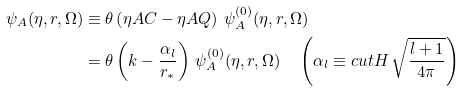Convert formula to latex. <formula><loc_0><loc_0><loc_500><loc_500>\psi _ { A } ( \eta , r , \Omega ) & \equiv \theta \left ( \eta A C - \eta A Q \right ) \, \psi ^ { ( 0 ) } _ { A } ( \eta , r , \Omega ) \\ & = \theta \left ( k - \frac { \alpha _ { l } } { r _ { * } } \right ) \, \psi ^ { ( 0 ) } _ { A } ( \eta , r , \Omega ) \quad \left ( \alpha _ { l } \equiv \L c u t H \, \sqrt { \frac { l + 1 } { 4 \pi } } \right )</formula> 